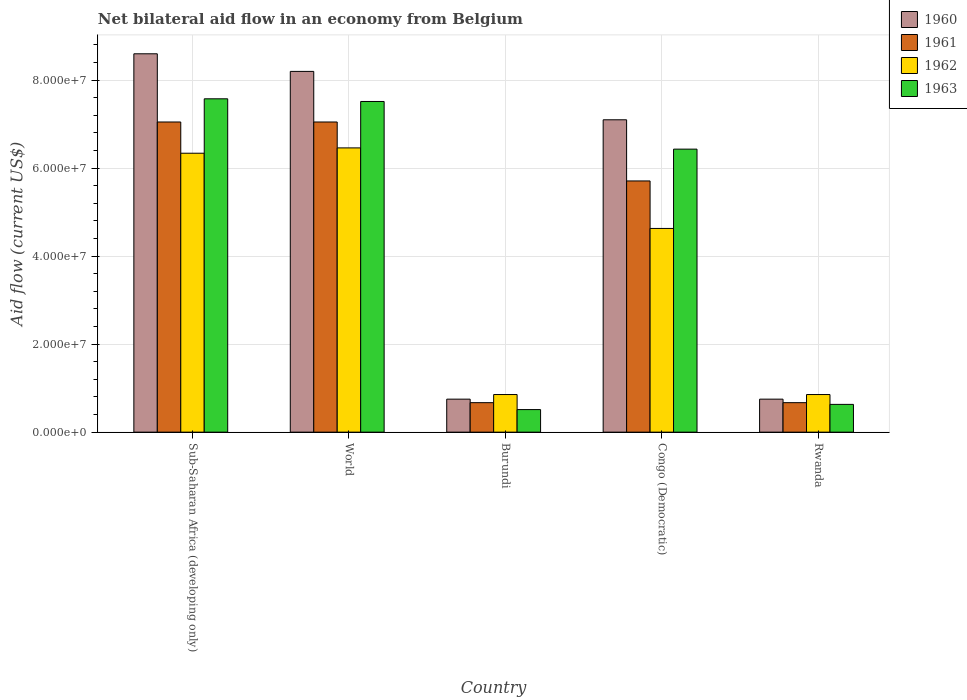How many different coloured bars are there?
Give a very brief answer. 4. Are the number of bars per tick equal to the number of legend labels?
Give a very brief answer. Yes. How many bars are there on the 1st tick from the left?
Keep it short and to the point. 4. What is the label of the 3rd group of bars from the left?
Provide a succinct answer. Burundi. In how many cases, is the number of bars for a given country not equal to the number of legend labels?
Your response must be concise. 0. What is the net bilateral aid flow in 1961 in Sub-Saharan Africa (developing only)?
Your answer should be very brief. 7.05e+07. Across all countries, what is the maximum net bilateral aid flow in 1961?
Make the answer very short. 7.05e+07. Across all countries, what is the minimum net bilateral aid flow in 1962?
Keep it short and to the point. 8.55e+06. In which country was the net bilateral aid flow in 1960 maximum?
Offer a terse response. Sub-Saharan Africa (developing only). In which country was the net bilateral aid flow in 1962 minimum?
Your response must be concise. Burundi. What is the total net bilateral aid flow in 1960 in the graph?
Ensure brevity in your answer.  2.54e+08. What is the difference between the net bilateral aid flow in 1962 in Rwanda and that in Sub-Saharan Africa (developing only)?
Your answer should be very brief. -5.48e+07. What is the average net bilateral aid flow in 1960 per country?
Offer a terse response. 5.08e+07. What is the difference between the net bilateral aid flow of/in 1963 and net bilateral aid flow of/in 1962 in Rwanda?
Offer a very short reply. -2.24e+06. What is the ratio of the net bilateral aid flow in 1961 in Congo (Democratic) to that in Rwanda?
Your response must be concise. 8.52. Is the difference between the net bilateral aid flow in 1963 in Burundi and Congo (Democratic) greater than the difference between the net bilateral aid flow in 1962 in Burundi and Congo (Democratic)?
Offer a very short reply. No. What is the difference between the highest and the second highest net bilateral aid flow in 1963?
Offer a terse response. 1.14e+07. What is the difference between the highest and the lowest net bilateral aid flow in 1960?
Your answer should be very brief. 7.85e+07. In how many countries, is the net bilateral aid flow in 1960 greater than the average net bilateral aid flow in 1960 taken over all countries?
Offer a very short reply. 3. Is the sum of the net bilateral aid flow in 1962 in Rwanda and Sub-Saharan Africa (developing only) greater than the maximum net bilateral aid flow in 1960 across all countries?
Keep it short and to the point. No. Is it the case that in every country, the sum of the net bilateral aid flow in 1962 and net bilateral aid flow in 1960 is greater than the sum of net bilateral aid flow in 1961 and net bilateral aid flow in 1963?
Your answer should be compact. No. What does the 2nd bar from the left in Congo (Democratic) represents?
Provide a short and direct response. 1961. What does the 1st bar from the right in Congo (Democratic) represents?
Your answer should be compact. 1963. How many bars are there?
Provide a succinct answer. 20. Where does the legend appear in the graph?
Your response must be concise. Top right. How are the legend labels stacked?
Provide a succinct answer. Vertical. What is the title of the graph?
Provide a short and direct response. Net bilateral aid flow in an economy from Belgium. What is the label or title of the X-axis?
Make the answer very short. Country. What is the Aid flow (current US$) of 1960 in Sub-Saharan Africa (developing only)?
Offer a very short reply. 8.60e+07. What is the Aid flow (current US$) of 1961 in Sub-Saharan Africa (developing only)?
Provide a short and direct response. 7.05e+07. What is the Aid flow (current US$) of 1962 in Sub-Saharan Africa (developing only)?
Keep it short and to the point. 6.34e+07. What is the Aid flow (current US$) of 1963 in Sub-Saharan Africa (developing only)?
Make the answer very short. 7.58e+07. What is the Aid flow (current US$) of 1960 in World?
Your answer should be compact. 8.20e+07. What is the Aid flow (current US$) of 1961 in World?
Your response must be concise. 7.05e+07. What is the Aid flow (current US$) of 1962 in World?
Your answer should be very brief. 6.46e+07. What is the Aid flow (current US$) of 1963 in World?
Your response must be concise. 7.52e+07. What is the Aid flow (current US$) in 1960 in Burundi?
Your answer should be very brief. 7.50e+06. What is the Aid flow (current US$) in 1961 in Burundi?
Keep it short and to the point. 6.70e+06. What is the Aid flow (current US$) in 1962 in Burundi?
Offer a terse response. 8.55e+06. What is the Aid flow (current US$) of 1963 in Burundi?
Your answer should be compact. 5.13e+06. What is the Aid flow (current US$) of 1960 in Congo (Democratic)?
Ensure brevity in your answer.  7.10e+07. What is the Aid flow (current US$) of 1961 in Congo (Democratic)?
Offer a very short reply. 5.71e+07. What is the Aid flow (current US$) in 1962 in Congo (Democratic)?
Ensure brevity in your answer.  4.63e+07. What is the Aid flow (current US$) of 1963 in Congo (Democratic)?
Provide a short and direct response. 6.43e+07. What is the Aid flow (current US$) in 1960 in Rwanda?
Make the answer very short. 7.50e+06. What is the Aid flow (current US$) of 1961 in Rwanda?
Your answer should be compact. 6.70e+06. What is the Aid flow (current US$) in 1962 in Rwanda?
Offer a very short reply. 8.55e+06. What is the Aid flow (current US$) in 1963 in Rwanda?
Offer a very short reply. 6.31e+06. Across all countries, what is the maximum Aid flow (current US$) in 1960?
Provide a short and direct response. 8.60e+07. Across all countries, what is the maximum Aid flow (current US$) in 1961?
Give a very brief answer. 7.05e+07. Across all countries, what is the maximum Aid flow (current US$) of 1962?
Your response must be concise. 6.46e+07. Across all countries, what is the maximum Aid flow (current US$) of 1963?
Offer a very short reply. 7.58e+07. Across all countries, what is the minimum Aid flow (current US$) of 1960?
Keep it short and to the point. 7.50e+06. Across all countries, what is the minimum Aid flow (current US$) in 1961?
Give a very brief answer. 6.70e+06. Across all countries, what is the minimum Aid flow (current US$) of 1962?
Keep it short and to the point. 8.55e+06. Across all countries, what is the minimum Aid flow (current US$) in 1963?
Offer a terse response. 5.13e+06. What is the total Aid flow (current US$) in 1960 in the graph?
Make the answer very short. 2.54e+08. What is the total Aid flow (current US$) of 1961 in the graph?
Your answer should be compact. 2.12e+08. What is the total Aid flow (current US$) of 1962 in the graph?
Give a very brief answer. 1.91e+08. What is the total Aid flow (current US$) of 1963 in the graph?
Your answer should be very brief. 2.27e+08. What is the difference between the Aid flow (current US$) in 1960 in Sub-Saharan Africa (developing only) and that in World?
Your response must be concise. 4.00e+06. What is the difference between the Aid flow (current US$) of 1962 in Sub-Saharan Africa (developing only) and that in World?
Your answer should be compact. -1.21e+06. What is the difference between the Aid flow (current US$) of 1960 in Sub-Saharan Africa (developing only) and that in Burundi?
Give a very brief answer. 7.85e+07. What is the difference between the Aid flow (current US$) of 1961 in Sub-Saharan Africa (developing only) and that in Burundi?
Provide a succinct answer. 6.38e+07. What is the difference between the Aid flow (current US$) in 1962 in Sub-Saharan Africa (developing only) and that in Burundi?
Provide a short and direct response. 5.48e+07. What is the difference between the Aid flow (current US$) of 1963 in Sub-Saharan Africa (developing only) and that in Burundi?
Ensure brevity in your answer.  7.06e+07. What is the difference between the Aid flow (current US$) in 1960 in Sub-Saharan Africa (developing only) and that in Congo (Democratic)?
Offer a very short reply. 1.50e+07. What is the difference between the Aid flow (current US$) in 1961 in Sub-Saharan Africa (developing only) and that in Congo (Democratic)?
Your answer should be very brief. 1.34e+07. What is the difference between the Aid flow (current US$) in 1962 in Sub-Saharan Africa (developing only) and that in Congo (Democratic)?
Make the answer very short. 1.71e+07. What is the difference between the Aid flow (current US$) in 1963 in Sub-Saharan Africa (developing only) and that in Congo (Democratic)?
Offer a very short reply. 1.14e+07. What is the difference between the Aid flow (current US$) in 1960 in Sub-Saharan Africa (developing only) and that in Rwanda?
Your answer should be compact. 7.85e+07. What is the difference between the Aid flow (current US$) of 1961 in Sub-Saharan Africa (developing only) and that in Rwanda?
Provide a short and direct response. 6.38e+07. What is the difference between the Aid flow (current US$) of 1962 in Sub-Saharan Africa (developing only) and that in Rwanda?
Provide a short and direct response. 5.48e+07. What is the difference between the Aid flow (current US$) of 1963 in Sub-Saharan Africa (developing only) and that in Rwanda?
Keep it short and to the point. 6.95e+07. What is the difference between the Aid flow (current US$) of 1960 in World and that in Burundi?
Your answer should be compact. 7.45e+07. What is the difference between the Aid flow (current US$) in 1961 in World and that in Burundi?
Your answer should be compact. 6.38e+07. What is the difference between the Aid flow (current US$) of 1962 in World and that in Burundi?
Offer a terse response. 5.61e+07. What is the difference between the Aid flow (current US$) in 1963 in World and that in Burundi?
Offer a very short reply. 7.00e+07. What is the difference between the Aid flow (current US$) in 1960 in World and that in Congo (Democratic)?
Make the answer very short. 1.10e+07. What is the difference between the Aid flow (current US$) in 1961 in World and that in Congo (Democratic)?
Keep it short and to the point. 1.34e+07. What is the difference between the Aid flow (current US$) in 1962 in World and that in Congo (Democratic)?
Your answer should be very brief. 1.83e+07. What is the difference between the Aid flow (current US$) in 1963 in World and that in Congo (Democratic)?
Keep it short and to the point. 1.08e+07. What is the difference between the Aid flow (current US$) in 1960 in World and that in Rwanda?
Offer a terse response. 7.45e+07. What is the difference between the Aid flow (current US$) in 1961 in World and that in Rwanda?
Provide a short and direct response. 6.38e+07. What is the difference between the Aid flow (current US$) in 1962 in World and that in Rwanda?
Give a very brief answer. 5.61e+07. What is the difference between the Aid flow (current US$) in 1963 in World and that in Rwanda?
Provide a short and direct response. 6.88e+07. What is the difference between the Aid flow (current US$) of 1960 in Burundi and that in Congo (Democratic)?
Offer a terse response. -6.35e+07. What is the difference between the Aid flow (current US$) in 1961 in Burundi and that in Congo (Democratic)?
Offer a very short reply. -5.04e+07. What is the difference between the Aid flow (current US$) in 1962 in Burundi and that in Congo (Democratic)?
Make the answer very short. -3.78e+07. What is the difference between the Aid flow (current US$) in 1963 in Burundi and that in Congo (Democratic)?
Your answer should be compact. -5.92e+07. What is the difference between the Aid flow (current US$) of 1963 in Burundi and that in Rwanda?
Give a very brief answer. -1.18e+06. What is the difference between the Aid flow (current US$) in 1960 in Congo (Democratic) and that in Rwanda?
Ensure brevity in your answer.  6.35e+07. What is the difference between the Aid flow (current US$) of 1961 in Congo (Democratic) and that in Rwanda?
Your answer should be compact. 5.04e+07. What is the difference between the Aid flow (current US$) of 1962 in Congo (Democratic) and that in Rwanda?
Provide a short and direct response. 3.78e+07. What is the difference between the Aid flow (current US$) in 1963 in Congo (Democratic) and that in Rwanda?
Your answer should be compact. 5.80e+07. What is the difference between the Aid flow (current US$) of 1960 in Sub-Saharan Africa (developing only) and the Aid flow (current US$) of 1961 in World?
Keep it short and to the point. 1.55e+07. What is the difference between the Aid flow (current US$) of 1960 in Sub-Saharan Africa (developing only) and the Aid flow (current US$) of 1962 in World?
Provide a succinct answer. 2.14e+07. What is the difference between the Aid flow (current US$) of 1960 in Sub-Saharan Africa (developing only) and the Aid flow (current US$) of 1963 in World?
Offer a terse response. 1.08e+07. What is the difference between the Aid flow (current US$) in 1961 in Sub-Saharan Africa (developing only) and the Aid flow (current US$) in 1962 in World?
Provide a short and direct response. 5.89e+06. What is the difference between the Aid flow (current US$) of 1961 in Sub-Saharan Africa (developing only) and the Aid flow (current US$) of 1963 in World?
Give a very brief answer. -4.66e+06. What is the difference between the Aid flow (current US$) in 1962 in Sub-Saharan Africa (developing only) and the Aid flow (current US$) in 1963 in World?
Your answer should be very brief. -1.18e+07. What is the difference between the Aid flow (current US$) in 1960 in Sub-Saharan Africa (developing only) and the Aid flow (current US$) in 1961 in Burundi?
Make the answer very short. 7.93e+07. What is the difference between the Aid flow (current US$) in 1960 in Sub-Saharan Africa (developing only) and the Aid flow (current US$) in 1962 in Burundi?
Give a very brief answer. 7.74e+07. What is the difference between the Aid flow (current US$) in 1960 in Sub-Saharan Africa (developing only) and the Aid flow (current US$) in 1963 in Burundi?
Make the answer very short. 8.09e+07. What is the difference between the Aid flow (current US$) of 1961 in Sub-Saharan Africa (developing only) and the Aid flow (current US$) of 1962 in Burundi?
Provide a short and direct response. 6.20e+07. What is the difference between the Aid flow (current US$) in 1961 in Sub-Saharan Africa (developing only) and the Aid flow (current US$) in 1963 in Burundi?
Keep it short and to the point. 6.54e+07. What is the difference between the Aid flow (current US$) in 1962 in Sub-Saharan Africa (developing only) and the Aid flow (current US$) in 1963 in Burundi?
Offer a very short reply. 5.83e+07. What is the difference between the Aid flow (current US$) of 1960 in Sub-Saharan Africa (developing only) and the Aid flow (current US$) of 1961 in Congo (Democratic)?
Provide a short and direct response. 2.89e+07. What is the difference between the Aid flow (current US$) of 1960 in Sub-Saharan Africa (developing only) and the Aid flow (current US$) of 1962 in Congo (Democratic)?
Your answer should be compact. 3.97e+07. What is the difference between the Aid flow (current US$) in 1960 in Sub-Saharan Africa (developing only) and the Aid flow (current US$) in 1963 in Congo (Democratic)?
Your response must be concise. 2.17e+07. What is the difference between the Aid flow (current US$) of 1961 in Sub-Saharan Africa (developing only) and the Aid flow (current US$) of 1962 in Congo (Democratic)?
Ensure brevity in your answer.  2.42e+07. What is the difference between the Aid flow (current US$) in 1961 in Sub-Saharan Africa (developing only) and the Aid flow (current US$) in 1963 in Congo (Democratic)?
Ensure brevity in your answer.  6.17e+06. What is the difference between the Aid flow (current US$) in 1962 in Sub-Saharan Africa (developing only) and the Aid flow (current US$) in 1963 in Congo (Democratic)?
Offer a very short reply. -9.30e+05. What is the difference between the Aid flow (current US$) in 1960 in Sub-Saharan Africa (developing only) and the Aid flow (current US$) in 1961 in Rwanda?
Give a very brief answer. 7.93e+07. What is the difference between the Aid flow (current US$) of 1960 in Sub-Saharan Africa (developing only) and the Aid flow (current US$) of 1962 in Rwanda?
Offer a terse response. 7.74e+07. What is the difference between the Aid flow (current US$) in 1960 in Sub-Saharan Africa (developing only) and the Aid flow (current US$) in 1963 in Rwanda?
Ensure brevity in your answer.  7.97e+07. What is the difference between the Aid flow (current US$) in 1961 in Sub-Saharan Africa (developing only) and the Aid flow (current US$) in 1962 in Rwanda?
Offer a terse response. 6.20e+07. What is the difference between the Aid flow (current US$) of 1961 in Sub-Saharan Africa (developing only) and the Aid flow (current US$) of 1963 in Rwanda?
Your answer should be very brief. 6.42e+07. What is the difference between the Aid flow (current US$) in 1962 in Sub-Saharan Africa (developing only) and the Aid flow (current US$) in 1963 in Rwanda?
Your answer should be compact. 5.71e+07. What is the difference between the Aid flow (current US$) in 1960 in World and the Aid flow (current US$) in 1961 in Burundi?
Your response must be concise. 7.53e+07. What is the difference between the Aid flow (current US$) in 1960 in World and the Aid flow (current US$) in 1962 in Burundi?
Offer a very short reply. 7.34e+07. What is the difference between the Aid flow (current US$) of 1960 in World and the Aid flow (current US$) of 1963 in Burundi?
Your answer should be very brief. 7.69e+07. What is the difference between the Aid flow (current US$) of 1961 in World and the Aid flow (current US$) of 1962 in Burundi?
Your answer should be very brief. 6.20e+07. What is the difference between the Aid flow (current US$) of 1961 in World and the Aid flow (current US$) of 1963 in Burundi?
Make the answer very short. 6.54e+07. What is the difference between the Aid flow (current US$) of 1962 in World and the Aid flow (current US$) of 1963 in Burundi?
Ensure brevity in your answer.  5.95e+07. What is the difference between the Aid flow (current US$) of 1960 in World and the Aid flow (current US$) of 1961 in Congo (Democratic)?
Your answer should be very brief. 2.49e+07. What is the difference between the Aid flow (current US$) of 1960 in World and the Aid flow (current US$) of 1962 in Congo (Democratic)?
Make the answer very short. 3.57e+07. What is the difference between the Aid flow (current US$) in 1960 in World and the Aid flow (current US$) in 1963 in Congo (Democratic)?
Make the answer very short. 1.77e+07. What is the difference between the Aid flow (current US$) of 1961 in World and the Aid flow (current US$) of 1962 in Congo (Democratic)?
Your answer should be compact. 2.42e+07. What is the difference between the Aid flow (current US$) of 1961 in World and the Aid flow (current US$) of 1963 in Congo (Democratic)?
Your answer should be compact. 6.17e+06. What is the difference between the Aid flow (current US$) of 1962 in World and the Aid flow (current US$) of 1963 in Congo (Democratic)?
Your response must be concise. 2.80e+05. What is the difference between the Aid flow (current US$) of 1960 in World and the Aid flow (current US$) of 1961 in Rwanda?
Your answer should be very brief. 7.53e+07. What is the difference between the Aid flow (current US$) in 1960 in World and the Aid flow (current US$) in 1962 in Rwanda?
Your response must be concise. 7.34e+07. What is the difference between the Aid flow (current US$) of 1960 in World and the Aid flow (current US$) of 1963 in Rwanda?
Ensure brevity in your answer.  7.57e+07. What is the difference between the Aid flow (current US$) of 1961 in World and the Aid flow (current US$) of 1962 in Rwanda?
Your answer should be very brief. 6.20e+07. What is the difference between the Aid flow (current US$) in 1961 in World and the Aid flow (current US$) in 1963 in Rwanda?
Keep it short and to the point. 6.42e+07. What is the difference between the Aid flow (current US$) in 1962 in World and the Aid flow (current US$) in 1963 in Rwanda?
Provide a short and direct response. 5.83e+07. What is the difference between the Aid flow (current US$) in 1960 in Burundi and the Aid flow (current US$) in 1961 in Congo (Democratic)?
Give a very brief answer. -4.96e+07. What is the difference between the Aid flow (current US$) of 1960 in Burundi and the Aid flow (current US$) of 1962 in Congo (Democratic)?
Give a very brief answer. -3.88e+07. What is the difference between the Aid flow (current US$) of 1960 in Burundi and the Aid flow (current US$) of 1963 in Congo (Democratic)?
Your response must be concise. -5.68e+07. What is the difference between the Aid flow (current US$) of 1961 in Burundi and the Aid flow (current US$) of 1962 in Congo (Democratic)?
Offer a very short reply. -3.96e+07. What is the difference between the Aid flow (current US$) of 1961 in Burundi and the Aid flow (current US$) of 1963 in Congo (Democratic)?
Keep it short and to the point. -5.76e+07. What is the difference between the Aid flow (current US$) of 1962 in Burundi and the Aid flow (current US$) of 1963 in Congo (Democratic)?
Keep it short and to the point. -5.58e+07. What is the difference between the Aid flow (current US$) in 1960 in Burundi and the Aid flow (current US$) in 1961 in Rwanda?
Keep it short and to the point. 8.00e+05. What is the difference between the Aid flow (current US$) of 1960 in Burundi and the Aid flow (current US$) of 1962 in Rwanda?
Offer a very short reply. -1.05e+06. What is the difference between the Aid flow (current US$) of 1960 in Burundi and the Aid flow (current US$) of 1963 in Rwanda?
Offer a terse response. 1.19e+06. What is the difference between the Aid flow (current US$) in 1961 in Burundi and the Aid flow (current US$) in 1962 in Rwanda?
Your response must be concise. -1.85e+06. What is the difference between the Aid flow (current US$) in 1961 in Burundi and the Aid flow (current US$) in 1963 in Rwanda?
Your answer should be very brief. 3.90e+05. What is the difference between the Aid flow (current US$) in 1962 in Burundi and the Aid flow (current US$) in 1963 in Rwanda?
Your answer should be compact. 2.24e+06. What is the difference between the Aid flow (current US$) of 1960 in Congo (Democratic) and the Aid flow (current US$) of 1961 in Rwanda?
Offer a terse response. 6.43e+07. What is the difference between the Aid flow (current US$) in 1960 in Congo (Democratic) and the Aid flow (current US$) in 1962 in Rwanda?
Make the answer very short. 6.24e+07. What is the difference between the Aid flow (current US$) in 1960 in Congo (Democratic) and the Aid flow (current US$) in 1963 in Rwanda?
Offer a very short reply. 6.47e+07. What is the difference between the Aid flow (current US$) in 1961 in Congo (Democratic) and the Aid flow (current US$) in 1962 in Rwanda?
Your answer should be very brief. 4.86e+07. What is the difference between the Aid flow (current US$) in 1961 in Congo (Democratic) and the Aid flow (current US$) in 1963 in Rwanda?
Provide a short and direct response. 5.08e+07. What is the difference between the Aid flow (current US$) of 1962 in Congo (Democratic) and the Aid flow (current US$) of 1963 in Rwanda?
Your answer should be compact. 4.00e+07. What is the average Aid flow (current US$) of 1960 per country?
Your response must be concise. 5.08e+07. What is the average Aid flow (current US$) in 1961 per country?
Give a very brief answer. 4.23e+07. What is the average Aid flow (current US$) of 1962 per country?
Make the answer very short. 3.83e+07. What is the average Aid flow (current US$) in 1963 per country?
Your answer should be very brief. 4.53e+07. What is the difference between the Aid flow (current US$) of 1960 and Aid flow (current US$) of 1961 in Sub-Saharan Africa (developing only)?
Give a very brief answer. 1.55e+07. What is the difference between the Aid flow (current US$) in 1960 and Aid flow (current US$) in 1962 in Sub-Saharan Africa (developing only)?
Your response must be concise. 2.26e+07. What is the difference between the Aid flow (current US$) of 1960 and Aid flow (current US$) of 1963 in Sub-Saharan Africa (developing only)?
Offer a very short reply. 1.02e+07. What is the difference between the Aid flow (current US$) of 1961 and Aid flow (current US$) of 1962 in Sub-Saharan Africa (developing only)?
Make the answer very short. 7.10e+06. What is the difference between the Aid flow (current US$) of 1961 and Aid flow (current US$) of 1963 in Sub-Saharan Africa (developing only)?
Keep it short and to the point. -5.27e+06. What is the difference between the Aid flow (current US$) in 1962 and Aid flow (current US$) in 1963 in Sub-Saharan Africa (developing only)?
Give a very brief answer. -1.24e+07. What is the difference between the Aid flow (current US$) in 1960 and Aid flow (current US$) in 1961 in World?
Ensure brevity in your answer.  1.15e+07. What is the difference between the Aid flow (current US$) of 1960 and Aid flow (current US$) of 1962 in World?
Keep it short and to the point. 1.74e+07. What is the difference between the Aid flow (current US$) in 1960 and Aid flow (current US$) in 1963 in World?
Keep it short and to the point. 6.84e+06. What is the difference between the Aid flow (current US$) of 1961 and Aid flow (current US$) of 1962 in World?
Provide a short and direct response. 5.89e+06. What is the difference between the Aid flow (current US$) in 1961 and Aid flow (current US$) in 1963 in World?
Your response must be concise. -4.66e+06. What is the difference between the Aid flow (current US$) of 1962 and Aid flow (current US$) of 1963 in World?
Offer a very short reply. -1.06e+07. What is the difference between the Aid flow (current US$) in 1960 and Aid flow (current US$) in 1961 in Burundi?
Provide a short and direct response. 8.00e+05. What is the difference between the Aid flow (current US$) in 1960 and Aid flow (current US$) in 1962 in Burundi?
Offer a very short reply. -1.05e+06. What is the difference between the Aid flow (current US$) in 1960 and Aid flow (current US$) in 1963 in Burundi?
Offer a very short reply. 2.37e+06. What is the difference between the Aid flow (current US$) in 1961 and Aid flow (current US$) in 1962 in Burundi?
Provide a succinct answer. -1.85e+06. What is the difference between the Aid flow (current US$) in 1961 and Aid flow (current US$) in 1963 in Burundi?
Your answer should be compact. 1.57e+06. What is the difference between the Aid flow (current US$) of 1962 and Aid flow (current US$) of 1963 in Burundi?
Keep it short and to the point. 3.42e+06. What is the difference between the Aid flow (current US$) in 1960 and Aid flow (current US$) in 1961 in Congo (Democratic)?
Ensure brevity in your answer.  1.39e+07. What is the difference between the Aid flow (current US$) in 1960 and Aid flow (current US$) in 1962 in Congo (Democratic)?
Your response must be concise. 2.47e+07. What is the difference between the Aid flow (current US$) of 1960 and Aid flow (current US$) of 1963 in Congo (Democratic)?
Give a very brief answer. 6.67e+06. What is the difference between the Aid flow (current US$) in 1961 and Aid flow (current US$) in 1962 in Congo (Democratic)?
Your answer should be very brief. 1.08e+07. What is the difference between the Aid flow (current US$) in 1961 and Aid flow (current US$) in 1963 in Congo (Democratic)?
Your response must be concise. -7.23e+06. What is the difference between the Aid flow (current US$) in 1962 and Aid flow (current US$) in 1963 in Congo (Democratic)?
Make the answer very short. -1.80e+07. What is the difference between the Aid flow (current US$) of 1960 and Aid flow (current US$) of 1962 in Rwanda?
Your answer should be compact. -1.05e+06. What is the difference between the Aid flow (current US$) of 1960 and Aid flow (current US$) of 1963 in Rwanda?
Provide a succinct answer. 1.19e+06. What is the difference between the Aid flow (current US$) of 1961 and Aid flow (current US$) of 1962 in Rwanda?
Keep it short and to the point. -1.85e+06. What is the difference between the Aid flow (current US$) in 1961 and Aid flow (current US$) in 1963 in Rwanda?
Provide a short and direct response. 3.90e+05. What is the difference between the Aid flow (current US$) of 1962 and Aid flow (current US$) of 1963 in Rwanda?
Provide a succinct answer. 2.24e+06. What is the ratio of the Aid flow (current US$) in 1960 in Sub-Saharan Africa (developing only) to that in World?
Your answer should be compact. 1.05. What is the ratio of the Aid flow (current US$) of 1962 in Sub-Saharan Africa (developing only) to that in World?
Provide a succinct answer. 0.98. What is the ratio of the Aid flow (current US$) in 1960 in Sub-Saharan Africa (developing only) to that in Burundi?
Ensure brevity in your answer.  11.47. What is the ratio of the Aid flow (current US$) in 1961 in Sub-Saharan Africa (developing only) to that in Burundi?
Provide a short and direct response. 10.52. What is the ratio of the Aid flow (current US$) of 1962 in Sub-Saharan Africa (developing only) to that in Burundi?
Your answer should be compact. 7.42. What is the ratio of the Aid flow (current US$) of 1963 in Sub-Saharan Africa (developing only) to that in Burundi?
Your answer should be very brief. 14.77. What is the ratio of the Aid flow (current US$) of 1960 in Sub-Saharan Africa (developing only) to that in Congo (Democratic)?
Give a very brief answer. 1.21. What is the ratio of the Aid flow (current US$) in 1961 in Sub-Saharan Africa (developing only) to that in Congo (Democratic)?
Provide a succinct answer. 1.23. What is the ratio of the Aid flow (current US$) of 1962 in Sub-Saharan Africa (developing only) to that in Congo (Democratic)?
Provide a succinct answer. 1.37. What is the ratio of the Aid flow (current US$) of 1963 in Sub-Saharan Africa (developing only) to that in Congo (Democratic)?
Provide a short and direct response. 1.18. What is the ratio of the Aid flow (current US$) of 1960 in Sub-Saharan Africa (developing only) to that in Rwanda?
Give a very brief answer. 11.47. What is the ratio of the Aid flow (current US$) in 1961 in Sub-Saharan Africa (developing only) to that in Rwanda?
Make the answer very short. 10.52. What is the ratio of the Aid flow (current US$) of 1962 in Sub-Saharan Africa (developing only) to that in Rwanda?
Your response must be concise. 7.42. What is the ratio of the Aid flow (current US$) of 1963 in Sub-Saharan Africa (developing only) to that in Rwanda?
Your answer should be compact. 12.01. What is the ratio of the Aid flow (current US$) of 1960 in World to that in Burundi?
Keep it short and to the point. 10.93. What is the ratio of the Aid flow (current US$) of 1961 in World to that in Burundi?
Your response must be concise. 10.52. What is the ratio of the Aid flow (current US$) in 1962 in World to that in Burundi?
Give a very brief answer. 7.56. What is the ratio of the Aid flow (current US$) of 1963 in World to that in Burundi?
Provide a short and direct response. 14.65. What is the ratio of the Aid flow (current US$) in 1960 in World to that in Congo (Democratic)?
Give a very brief answer. 1.15. What is the ratio of the Aid flow (current US$) in 1961 in World to that in Congo (Democratic)?
Provide a succinct answer. 1.23. What is the ratio of the Aid flow (current US$) of 1962 in World to that in Congo (Democratic)?
Keep it short and to the point. 1.4. What is the ratio of the Aid flow (current US$) of 1963 in World to that in Congo (Democratic)?
Offer a terse response. 1.17. What is the ratio of the Aid flow (current US$) of 1960 in World to that in Rwanda?
Make the answer very short. 10.93. What is the ratio of the Aid flow (current US$) in 1961 in World to that in Rwanda?
Give a very brief answer. 10.52. What is the ratio of the Aid flow (current US$) of 1962 in World to that in Rwanda?
Your response must be concise. 7.56. What is the ratio of the Aid flow (current US$) in 1963 in World to that in Rwanda?
Offer a very short reply. 11.91. What is the ratio of the Aid flow (current US$) of 1960 in Burundi to that in Congo (Democratic)?
Your answer should be compact. 0.11. What is the ratio of the Aid flow (current US$) in 1961 in Burundi to that in Congo (Democratic)?
Make the answer very short. 0.12. What is the ratio of the Aid flow (current US$) of 1962 in Burundi to that in Congo (Democratic)?
Ensure brevity in your answer.  0.18. What is the ratio of the Aid flow (current US$) in 1963 in Burundi to that in Congo (Democratic)?
Offer a terse response. 0.08. What is the ratio of the Aid flow (current US$) in 1960 in Burundi to that in Rwanda?
Offer a terse response. 1. What is the ratio of the Aid flow (current US$) in 1961 in Burundi to that in Rwanda?
Your answer should be very brief. 1. What is the ratio of the Aid flow (current US$) of 1962 in Burundi to that in Rwanda?
Your answer should be compact. 1. What is the ratio of the Aid flow (current US$) of 1963 in Burundi to that in Rwanda?
Make the answer very short. 0.81. What is the ratio of the Aid flow (current US$) in 1960 in Congo (Democratic) to that in Rwanda?
Ensure brevity in your answer.  9.47. What is the ratio of the Aid flow (current US$) of 1961 in Congo (Democratic) to that in Rwanda?
Your response must be concise. 8.52. What is the ratio of the Aid flow (current US$) in 1962 in Congo (Democratic) to that in Rwanda?
Your response must be concise. 5.42. What is the ratio of the Aid flow (current US$) in 1963 in Congo (Democratic) to that in Rwanda?
Make the answer very short. 10.19. What is the difference between the highest and the second highest Aid flow (current US$) of 1961?
Offer a terse response. 0. What is the difference between the highest and the second highest Aid flow (current US$) in 1962?
Your answer should be very brief. 1.21e+06. What is the difference between the highest and the lowest Aid flow (current US$) of 1960?
Your answer should be compact. 7.85e+07. What is the difference between the highest and the lowest Aid flow (current US$) of 1961?
Give a very brief answer. 6.38e+07. What is the difference between the highest and the lowest Aid flow (current US$) of 1962?
Give a very brief answer. 5.61e+07. What is the difference between the highest and the lowest Aid flow (current US$) in 1963?
Your answer should be compact. 7.06e+07. 